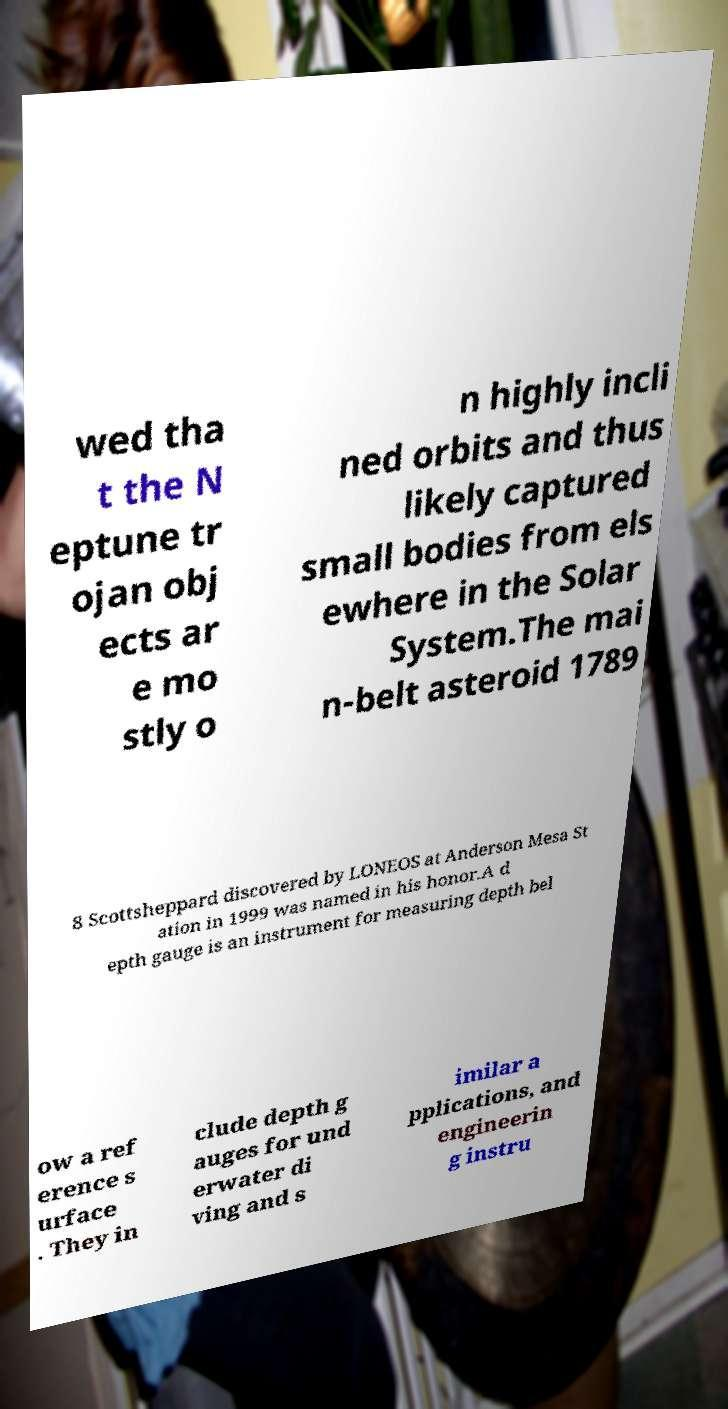Please read and relay the text visible in this image. What does it say? wed tha t the N eptune tr ojan obj ects ar e mo stly o n highly incli ned orbits and thus likely captured small bodies from els ewhere in the Solar System.The mai n-belt asteroid 1789 8 Scottsheppard discovered by LONEOS at Anderson Mesa St ation in 1999 was named in his honor.A d epth gauge is an instrument for measuring depth bel ow a ref erence s urface . They in clude depth g auges for und erwater di ving and s imilar a pplications, and engineerin g instru 